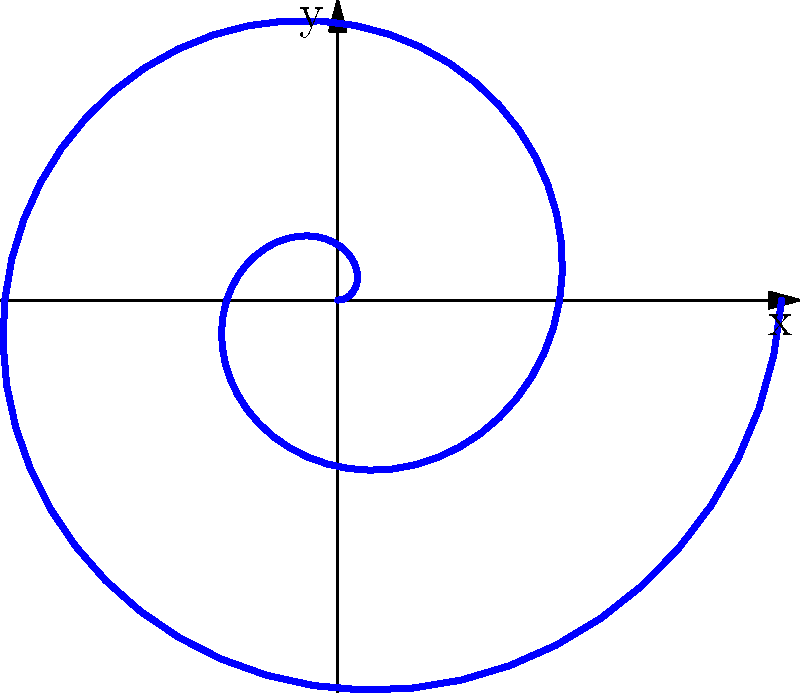In creating a unique NFT design featuring a spiral pattern, you decide to use polar coordinates. If the equation for the spiral is given by $r = 0.2\theta$, where $r$ is the radius and $\theta$ is the angle in radians, what is the maximum value of $r$ when $\theta$ ranges from 0 to $4\pi$? To find the maximum value of $r$, we need to follow these steps:

1. Understand the given equation: $r = 0.2\theta$

2. Identify the range of $\theta$: 
   $0 \leq \theta \leq 4\pi$

3. The maximum value of $r$ will occur at the maximum value of $\theta$, which is $4\pi$

4. Calculate $r$ at $\theta = 4\pi$:
   $r_{max} = 0.2 * 4\pi$
   $r_{max} = 0.2 * 4 * 3.14159...$
   $r_{max} \approx 2.51327$

5. Round to two decimal places for a concise answer:
   $r_{max} \approx 2.51$

This maximum radius represents the outermost point of the spiral in your NFT design, creating a unique and mathematically-derived pattern.
Answer: 2.51 